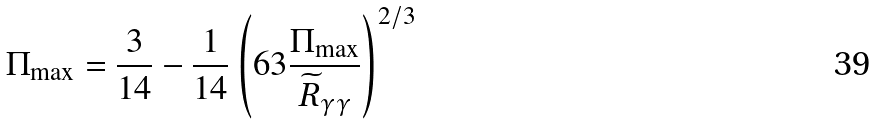Convert formula to latex. <formula><loc_0><loc_0><loc_500><loc_500>\Pi _ { \max } = \frac { 3 } { 1 4 } - \frac { 1 } { 1 4 } \left ( 6 3 \frac { \Pi _ { \max } } { \widetilde { R } _ { \gamma \gamma } } \right ) ^ { 2 / 3 }</formula> 